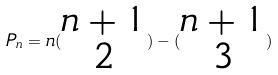<formula> <loc_0><loc_0><loc_500><loc_500>P _ { n } = n ( \begin{matrix} n + 1 \\ 2 \end{matrix} ) - ( \begin{matrix} n + 1 \\ 3 \end{matrix} )</formula> 